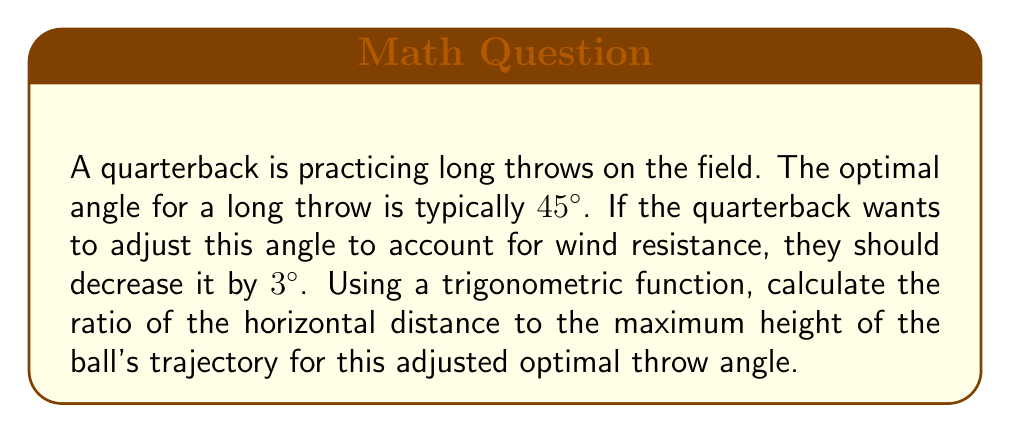Give your solution to this math problem. Let's approach this step-by-step:

1) The adjusted optimal angle is 45° - 3° = 42°.

2) The ratio of horizontal distance to maximum height in a projectile motion is given by the tangent of twice the launch angle:

   $$ \frac{\text{Horizontal Distance}}{\text{Maximum Height}} = \tan(2\theta) $$

   where $\theta$ is the launch angle.

3) Substituting our adjusted angle:

   $$ \frac{\text{Horizontal Distance}}{\text{Maximum Height}} = \tan(2 * 42°) = \tan(84°) $$

4) To calculate $\tan(84°)$:
   
   $\tan(84°) \approx 9.5144$

5) This means the horizontal distance is approximately 9.5144 times the maximum height.

[asy]
import geometry;

size(200);
pair O=(0,0), A=(10,0), B=(10,9.5144);
draw(O--A--B--O);
label("42°", O, SW);
label("Horizontal Distance", (5,0), S);
label("Max Height", (10,4.7572), E);
[/asy]
Answer: $9.5144:1$ 